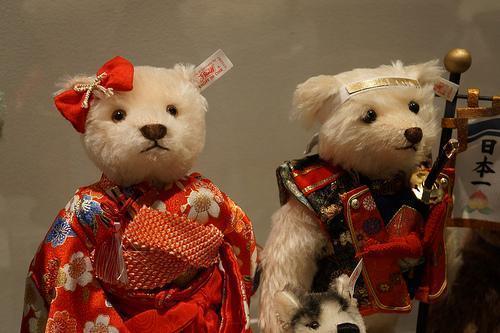How many toy bears are there?
Give a very brief answer. 2. 